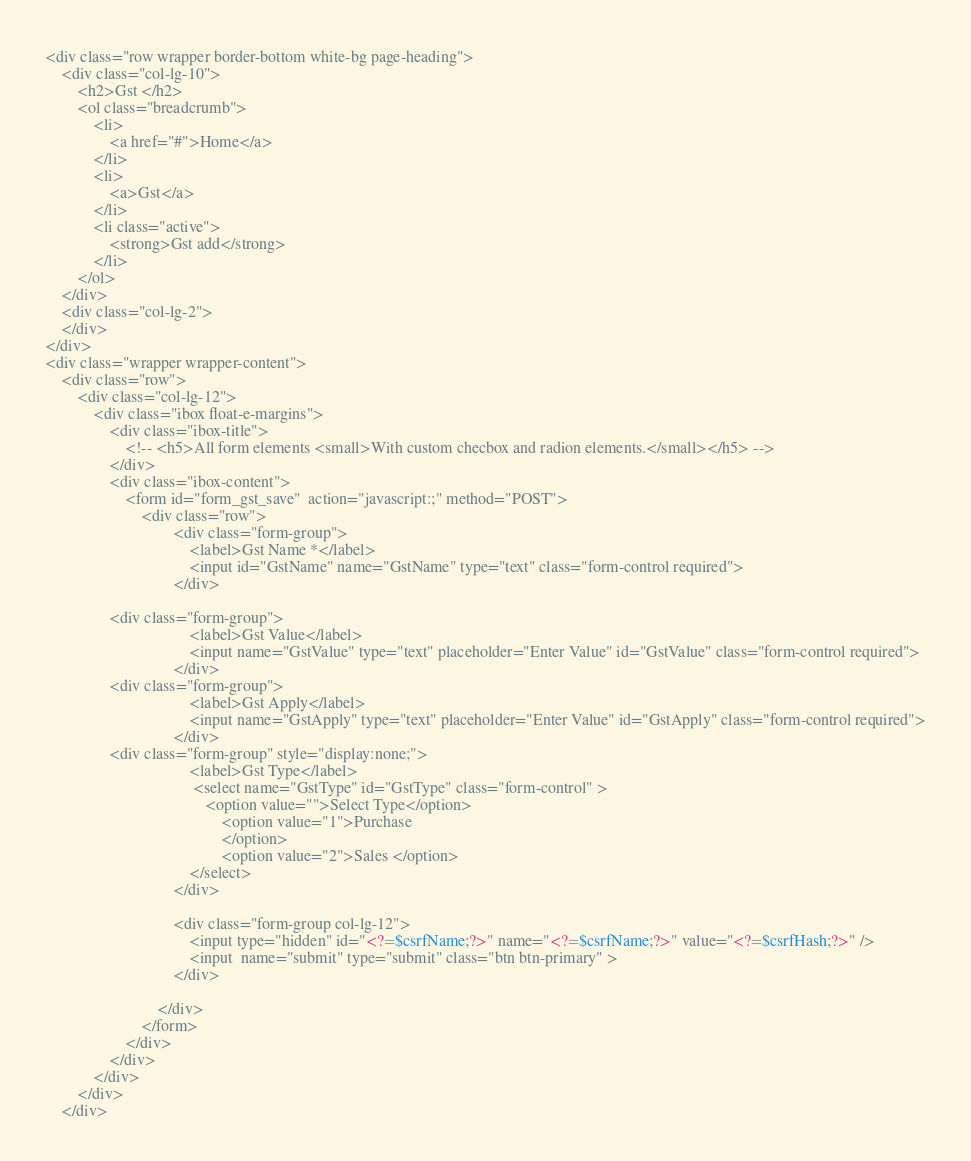<code> <loc_0><loc_0><loc_500><loc_500><_PHP_><div class="row wrapper border-bottom white-bg page-heading">
    <div class="col-lg-10">
        <h2>Gst </h2>
        <ol class="breadcrumb">
            <li>
                <a href="#">Home</a>
            </li>
            <li>
                <a>Gst</a>
            </li>
            <li class="active">
                <strong>Gst add</strong>
            </li>
        </ol>
    </div>
    <div class="col-lg-2">
    </div>
</div>
<div class="wrapper wrapper-content">
    <div class="row">
        <div class="col-lg-12">
            <div class="ibox float-e-margins">
                <div class="ibox-title">
                    <!-- <h5>All form elements <small>With custom checbox and radion elements.</small></h5> -->
                </div>
                <div class="ibox-content">
                    <form id="form_gst_save"  action="javascript:;" method="POST">
                        <div class="row">
                                <div class="form-group">
                                    <label>Gst Name *</label>
                                    <input id="GstName" name="GstName" type="text" class="form-control required">
                                </div>
								
				<div class="form-group">
                                    <label>Gst Value</label>
                                    <input name="GstValue" type="text" placeholder="Enter Value" id="GstValue" class="form-control required">
                                </div>
				<div class="form-group">
                                    <label>Gst Apply</label>
                                    <input name="GstApply" type="text" placeholder="Enter Value" id="GstApply" class="form-control required">
                                </div>				
				<div class="form-group" style="display:none;">
                                    <label>Gst Type</label>
                                     <select name="GstType" id="GstType" class="form-control" >
                                        <option value="">Select Type</option>                                      
                                            <option value="1">Purchase
                                            </option>										
                                            <option value="2">Sales </option>                                        
                                    </select>
                                </div>
										
                                <div class="form-group col-lg-12">
                                    <input type="hidden" id="<?=$csrfName;?>" name="<?=$csrfName;?>" value="<?=$csrfHash;?>" />
                                    <input  name="submit" type="submit" class="btn btn-primary" >
                                </div>

                            </div>
                        </form>
                    </div>
                </div>
            </div>
        </div>
    </div>
</code> 